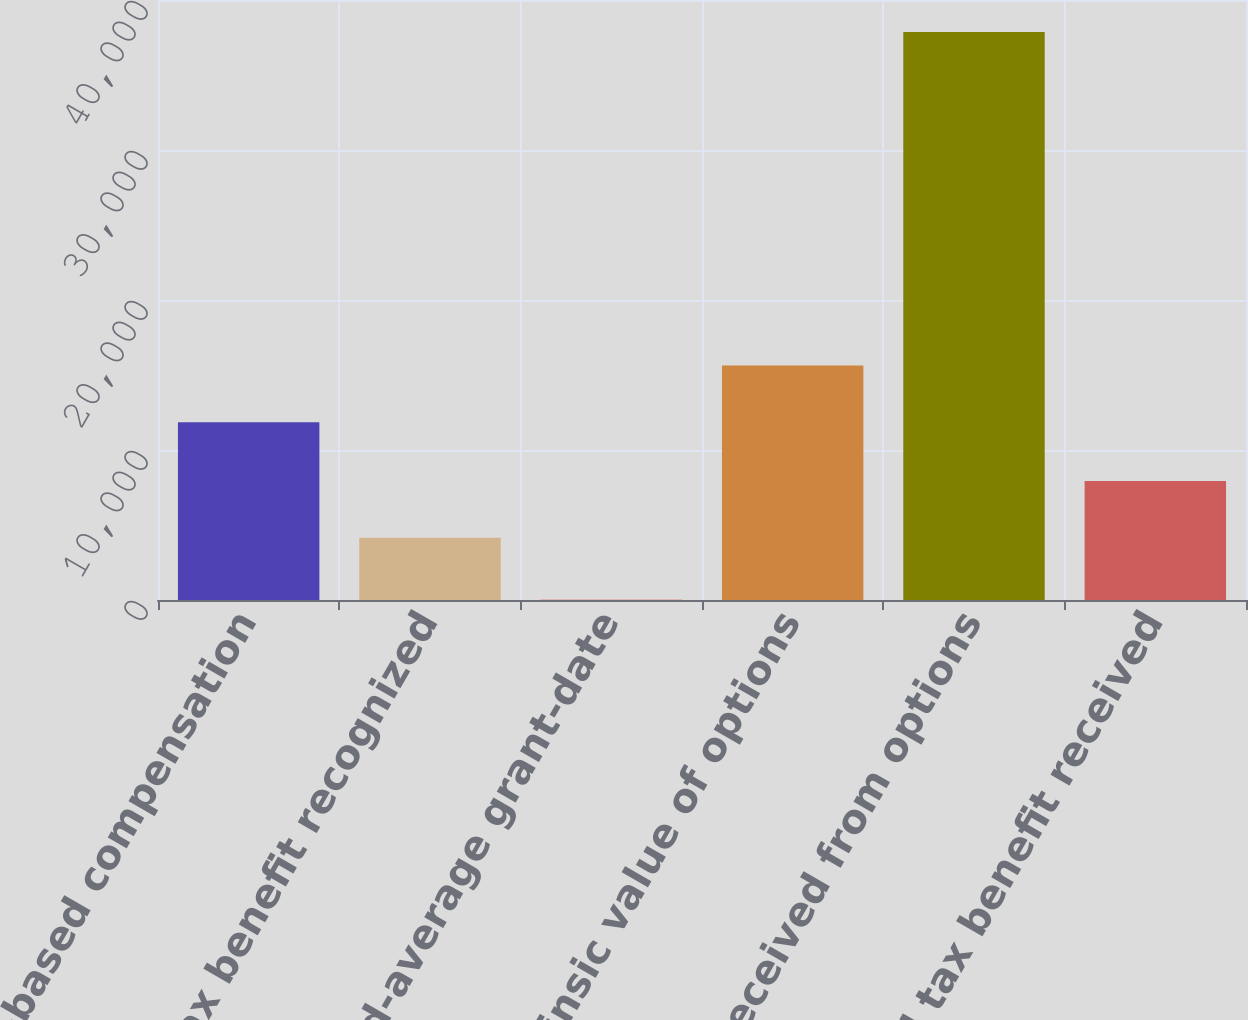Convert chart. <chart><loc_0><loc_0><loc_500><loc_500><bar_chart><fcel>Stock-based compensation<fcel>Tax benefit recognized<fcel>Weighted-average grant-date<fcel>Intrinsic value of options<fcel>Cash received from options<fcel>Actual tax benefit received<nl><fcel>11848<fcel>4147<fcel>10.35<fcel>15633.3<fcel>37863<fcel>7932.27<nl></chart> 